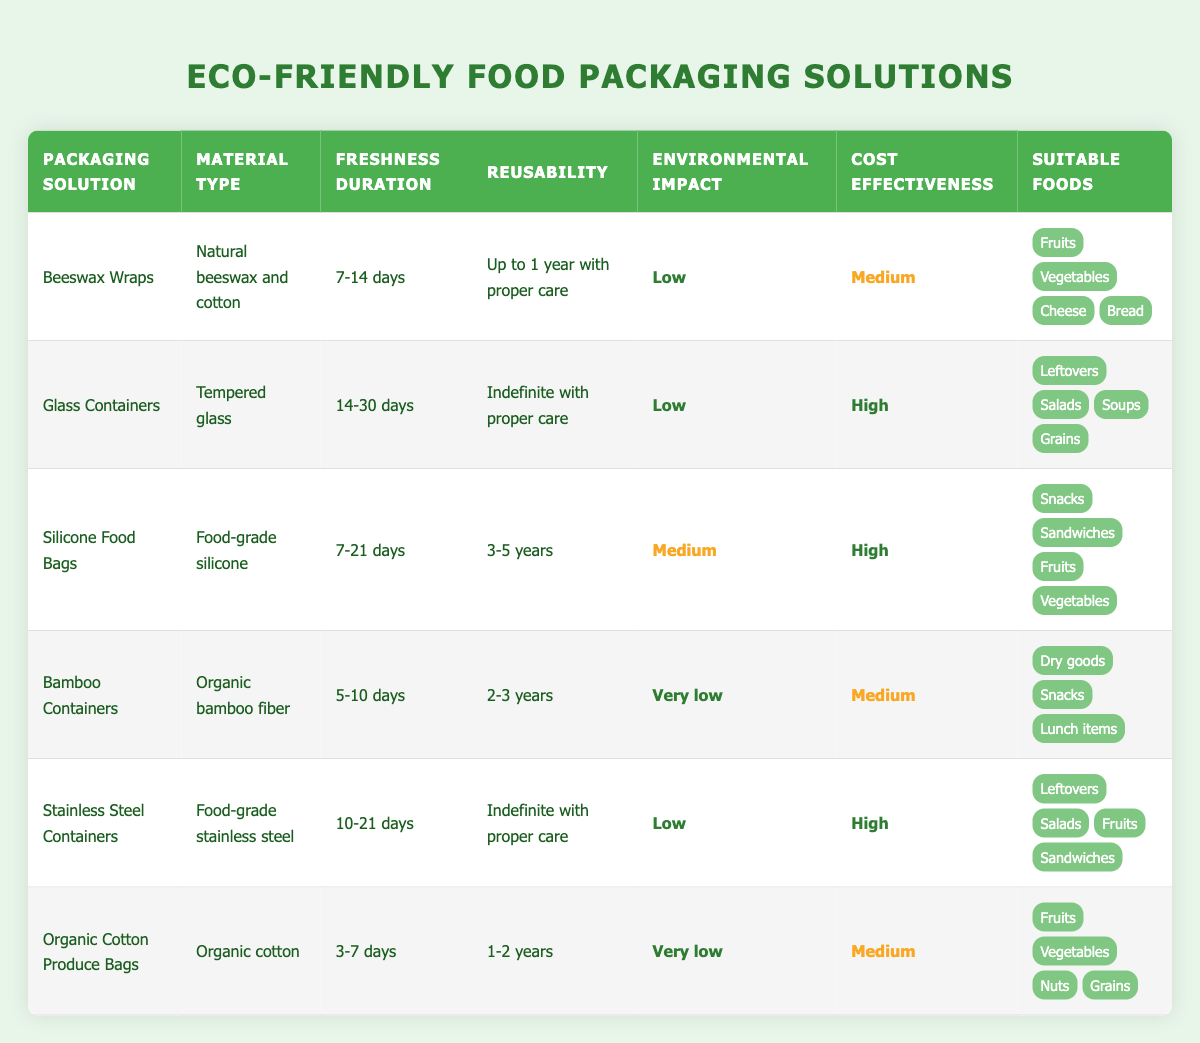What is the freshness duration of Beeswax Wraps? The table shows that the freshness duration of Beeswax Wraps is 7-14 days, indicated in the relevant column.
Answer: 7-14 days Which packaging solution has the highest reusability? The packaging solutions with the highest reusability are Glass Containers and Stainless Steel Containers, both of which can be reused indefinitely with proper care.
Answer: Glass Containers and Stainless Steel Containers What environmental impact classification does Bamboo Containers belong to? According to the table, Bamboo Containers have a very low environmental impact, as denoted in the respective column.
Answer: Very low Which packaging solution is suitable for the most types of foods? By examining the "Suitable Foods" column, it’s evident that both Glass Containers and Stainless Steel Containers can store four different types of food, which is the highest among all options.
Answer: Glass Containers and Stainless Steel Containers Which packaging solution offers the longest freshness duration? The table shows that Glass Containers have the longest freshness duration of 14-30 days, as it’s listed in the "Freshness Duration" column.
Answer: 14-30 days Is it true that Organic Cotton Produce Bags have a higher freshness duration than Bamboo Containers? Comparing the values for freshness duration, Organic Cotton Produce Bags last 3-7 days, while Bamboo Containers last 5-10 days. Thus, Organic Cotton Produce Bags do not have a higher freshness duration.
Answer: No What is the average cost effectiveness of all the solutions listed? The cost effectiveness ratings are: Medium (5 entries), High (3 entries). For average calculation, we can weigh them as Medium=1, High=2. The average calculation is (1*5 + 2*3) / 8 = (5 + 6) / 8 = 11/8 = 1.375, which equates to Medium since the average stays closer to one of the values than two.
Answer: Medium Which solutions can be reused for at least 2 years? The solutions with reusability of at least 2 years are Silicone Food Bags (3-5 years), Bamboo Containers (2-3 years), and Organic Cotton Produce Bags (1-2 years). However, only Silicone Food Bags and Bamboo Containers meet this criterion.
Answer: Silicone Food Bags and Bamboo Containers What is the cost effectiveness of Beeswax Wraps compared to that of Glass Containers? The table indicates that Beeswax Wraps are classified as Medium in cost effectiveness, while Glass Containers are classified as High, hence Beeswax Wraps have a lower cost effectiveness than Glass Containers.
Answer: Lower 